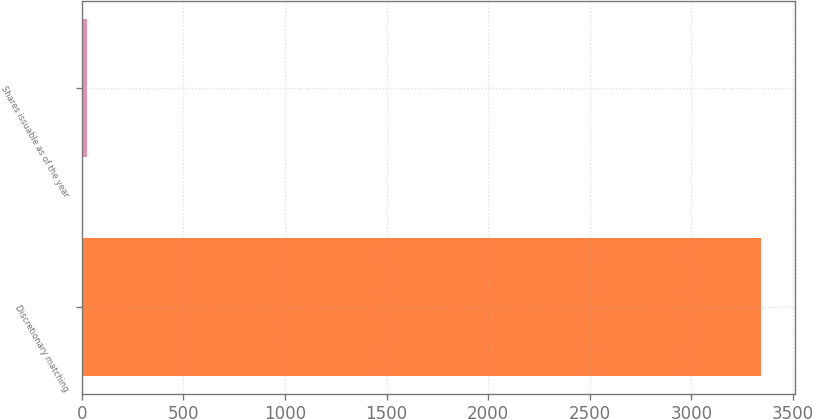<chart> <loc_0><loc_0><loc_500><loc_500><bar_chart><fcel>Discretionary matching<fcel>Shares issuable as of the year<nl><fcel>3341<fcel>28<nl></chart> 